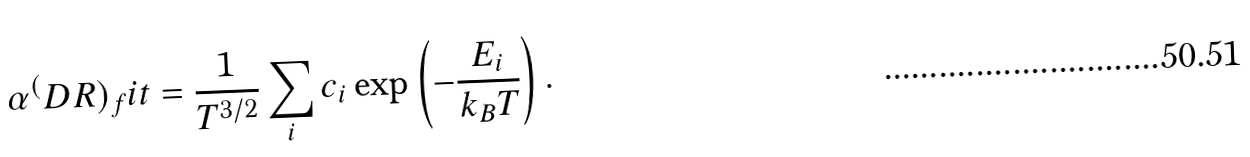<formula> <loc_0><loc_0><loc_500><loc_500>\alpha ^ { ( } D R ) _ { f } i t = \frac { 1 } { T ^ { 3 / 2 } } \sum _ { i } c _ { i } \exp \left ( - \frac { E _ { i } } { k _ { B } T } \right ) .</formula> 